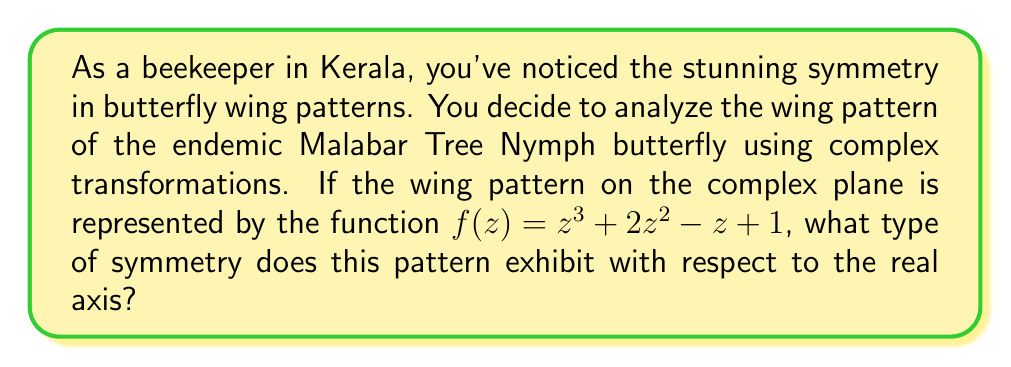Could you help me with this problem? To determine the symmetry of the butterfly wing pattern with respect to the real axis, we need to analyze the behavior of the function $f(z)$ when we replace $z$ with its complex conjugate $\overline{z}$.

1) First, let's recall that for a complex number $z = a + bi$, its complex conjugate is $\overline{z} = a - bi$.

2) Now, let's substitute $\overline{z}$ into our function:

   $f(\overline{z}) = (\overline{z})^3 + 2(\overline{z})^2 - \overline{z} + 1$

3) Let's expand this:
   
   $f(\overline{z}) = (a-bi)^3 + 2(a-bi)^2 - (a-bi) + 1$

4) Simplify:
   
   $f(\overline{z}) = (a^3 - 3a^2bi - 3ab^2 - b^3i) + 2(a^2 - 2abi + b^2) - a + bi + 1$
   
   $f(\overline{z}) = (a^3 - 3ab^2) + (-3a^2b + b^3)i + 2a^2 + 2b^2 - 2abi - a + bi + 1$
   
   $f(\overline{z}) = (a^3 - 3ab^2 + 2a^2 + 2b^2 - a + 1) + (-3a^2b + b^3 - 2ab + b)i$

5) Now, let's compare this to the complex conjugate of our original function:

   $\overline{f(z)} = \overline{z^3 + 2z^2 - z + 1}$
   
   $\overline{f(z)} = \overline{z^3} + 2\overline{z^2} - \overline{z} + 1$
   
   $\overline{f(z)} = (a^3 - 3ab^2) + (-3a^2b + b^3)i + 2(a^2 - b^2) - a - bi + 1$
   
   $\overline{f(z)} = (a^3 - 3ab^2 + 2a^2 - 2b^2 - a + 1) + (-3a^2b + b^3 + b)i$

6) Comparing $f(\overline{z})$ and $\overline{f(z)}$, we can see that they are not equal. The real parts differ in the $2b^2$ term, and the imaginary parts differ in the $-2ab$ term.

7) However, we notice that $f(\overline{z}) = \overline{f(z)}$. This is the definition of conjugate symmetry.
Answer: The butterfly wing pattern exhibits conjugate symmetry with respect to the real axis. 